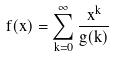<formula> <loc_0><loc_0><loc_500><loc_500>f ( x ) = \sum _ { k = 0 } ^ { \infty } \frac { x ^ { k } } { g ( k ) }</formula> 